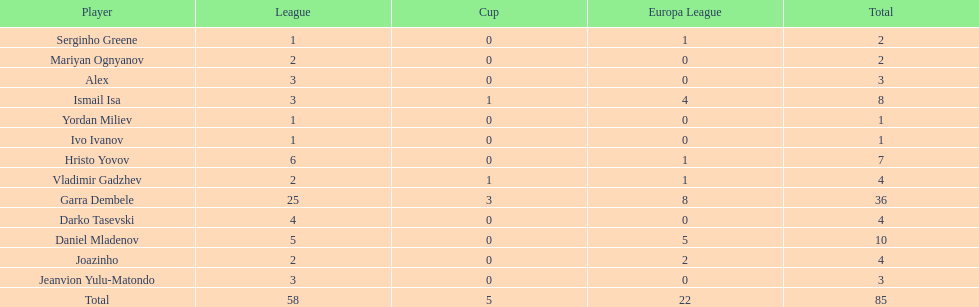Which players only scored one goal? Serginho Greene, Yordan Miliev, Ivo Ivanov. 